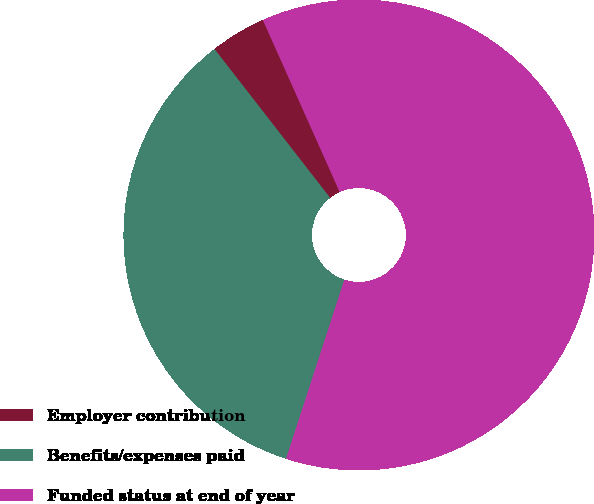Convert chart to OTSL. <chart><loc_0><loc_0><loc_500><loc_500><pie_chart><fcel>Employer contribution<fcel>Benefits/expenses paid<fcel>Funded status at end of year<nl><fcel>3.83%<fcel>34.48%<fcel>61.69%<nl></chart> 